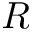Convert formula to latex. <formula><loc_0><loc_0><loc_500><loc_500>R</formula> 